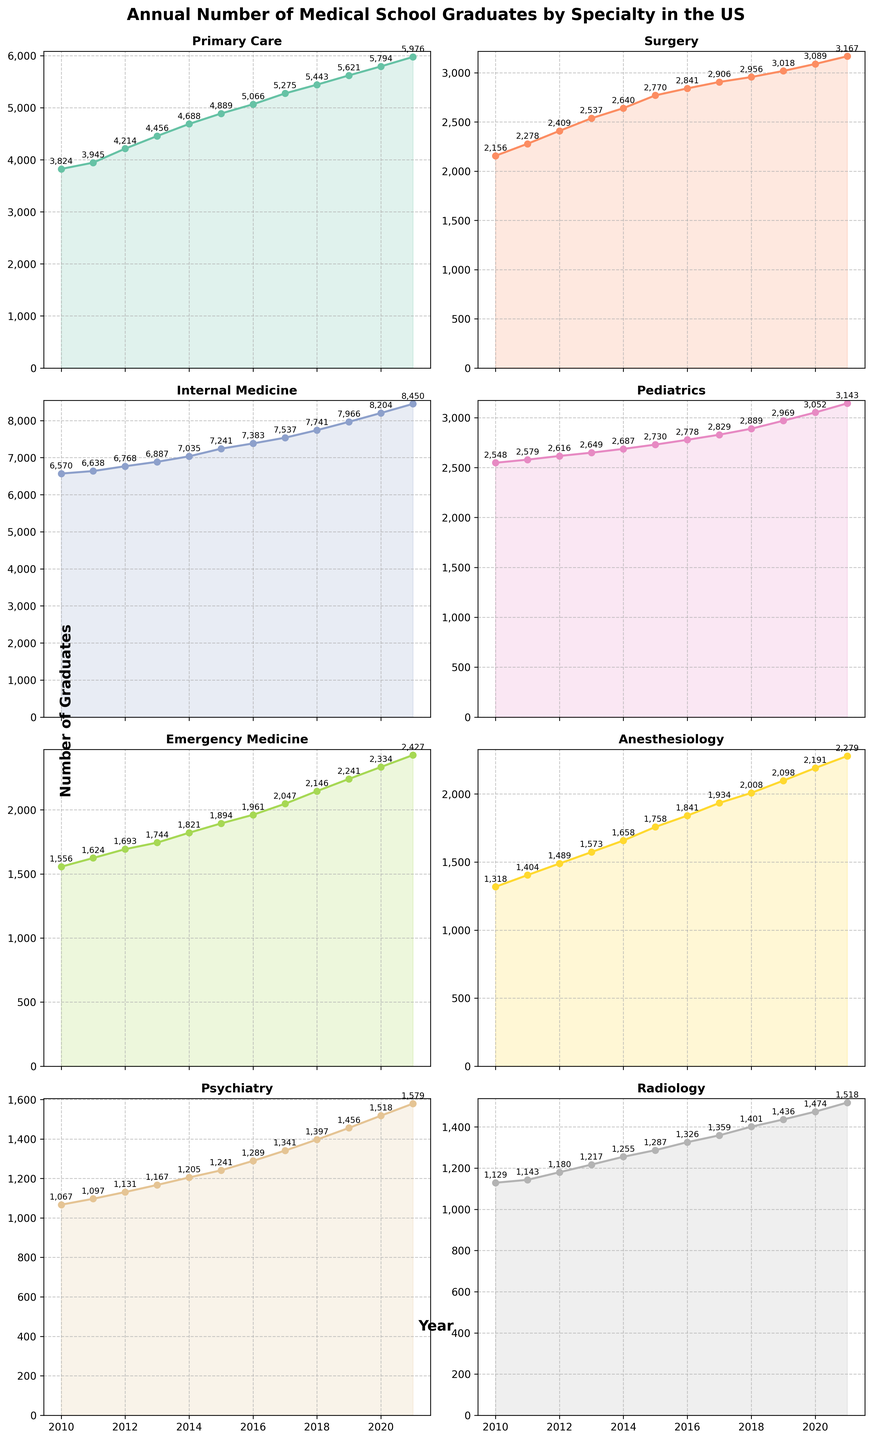What is the trend in the number of Primary Care graduates from 2010 to 2021? The number of Primary Care graduates shows a consistent increase from 3,824 in 2010 to 5,976 in 2021, indicating a positive growth trend over the years.
Answer: Increasing Which specialty had the highest number of graduates in 2021? By observing the plots, we see that Internal Medicine had the highest count with 8,450 graduates in 2021.
Answer: Internal Medicine Compare the number of Pediatric graduates in 2010 and 2021. How much did it change? In 2010, there were 2,548 Pediatric graduates, while in 2021, there were 3,143 graduates. The change is 3,143 - 2,548 = 595.
Answer: Increased by 595 Which specialty had the least growth in the number of graduates from 2010 to 2021? Comparing the growth visually across all subplots, Radiology shows the least growth from 1,129 in 2010 to 1,518 in 2021, which is an increase of 389.
Answer: Radiology What is the combined total number of graduates in Surgery and Radiology in 2021? Surgery had 3,167 graduates and Radiology had 1,518 graduates in 2021. The combined total is 3,167 + 1,518 = 4,685.
Answer: 4,685 Identify which specialty had a sharper increase from 2015 to 2021, Anesthesiology or Emergency Medicine. From the plots: 
- Anesthesiology increased from 1,758 in 2015 to 2,279 in 2021, which is a difference of 521. 
- Emergency Medicine increased from 1,894 in 2015 to 2,427 in 2021, which is a difference of 533. 
Therefore, Emergency Medicine had a sharper increase.
Answer: Emergency Medicine What visual features distinguish the trend line for Psychiatry? The Psychiatry trend line is characterized by a relatively moderate slope, indicating steady growth. The line is marked with an increasing gradient but does not show any sudden spikes or drops. It has a noticeable gradient compared to other specialties.
Answer: Steady growth, moderate slope Which years show the most significant increases for Internal Medicine? Observing the plot for Internal Medicine, significant increases are noted between the years 2014-2015 and 2019-2020 where the growth seems steeper compared to other periods.
Answer: 2014-2015 and 2019-2020 Compare the number of graduates in Pediatrics and Psychiatry in 2015. Which had more, and by how much? In 2015, Pediatrics had 2,730 graduates, and Psychiatry had 1,241 graduates. Pediatrics had 2,730 - 1,241 = 1,489 more graduates.
Answer: Pediatrics by 1,489 What is the average annual increase in graduates for Surgery from 2010 to 2021? Surgery graduates increased from 2,156 in 2010 to 3,167 in 2021. The total increase is 3,167 - 2,156 = 1,011. The period is 2021 - 2010 = 11 years. Thus, the average annual increase is 1,011 / 11 ≈ 92 graduates per year.
Answer: ~92 graduates per year 